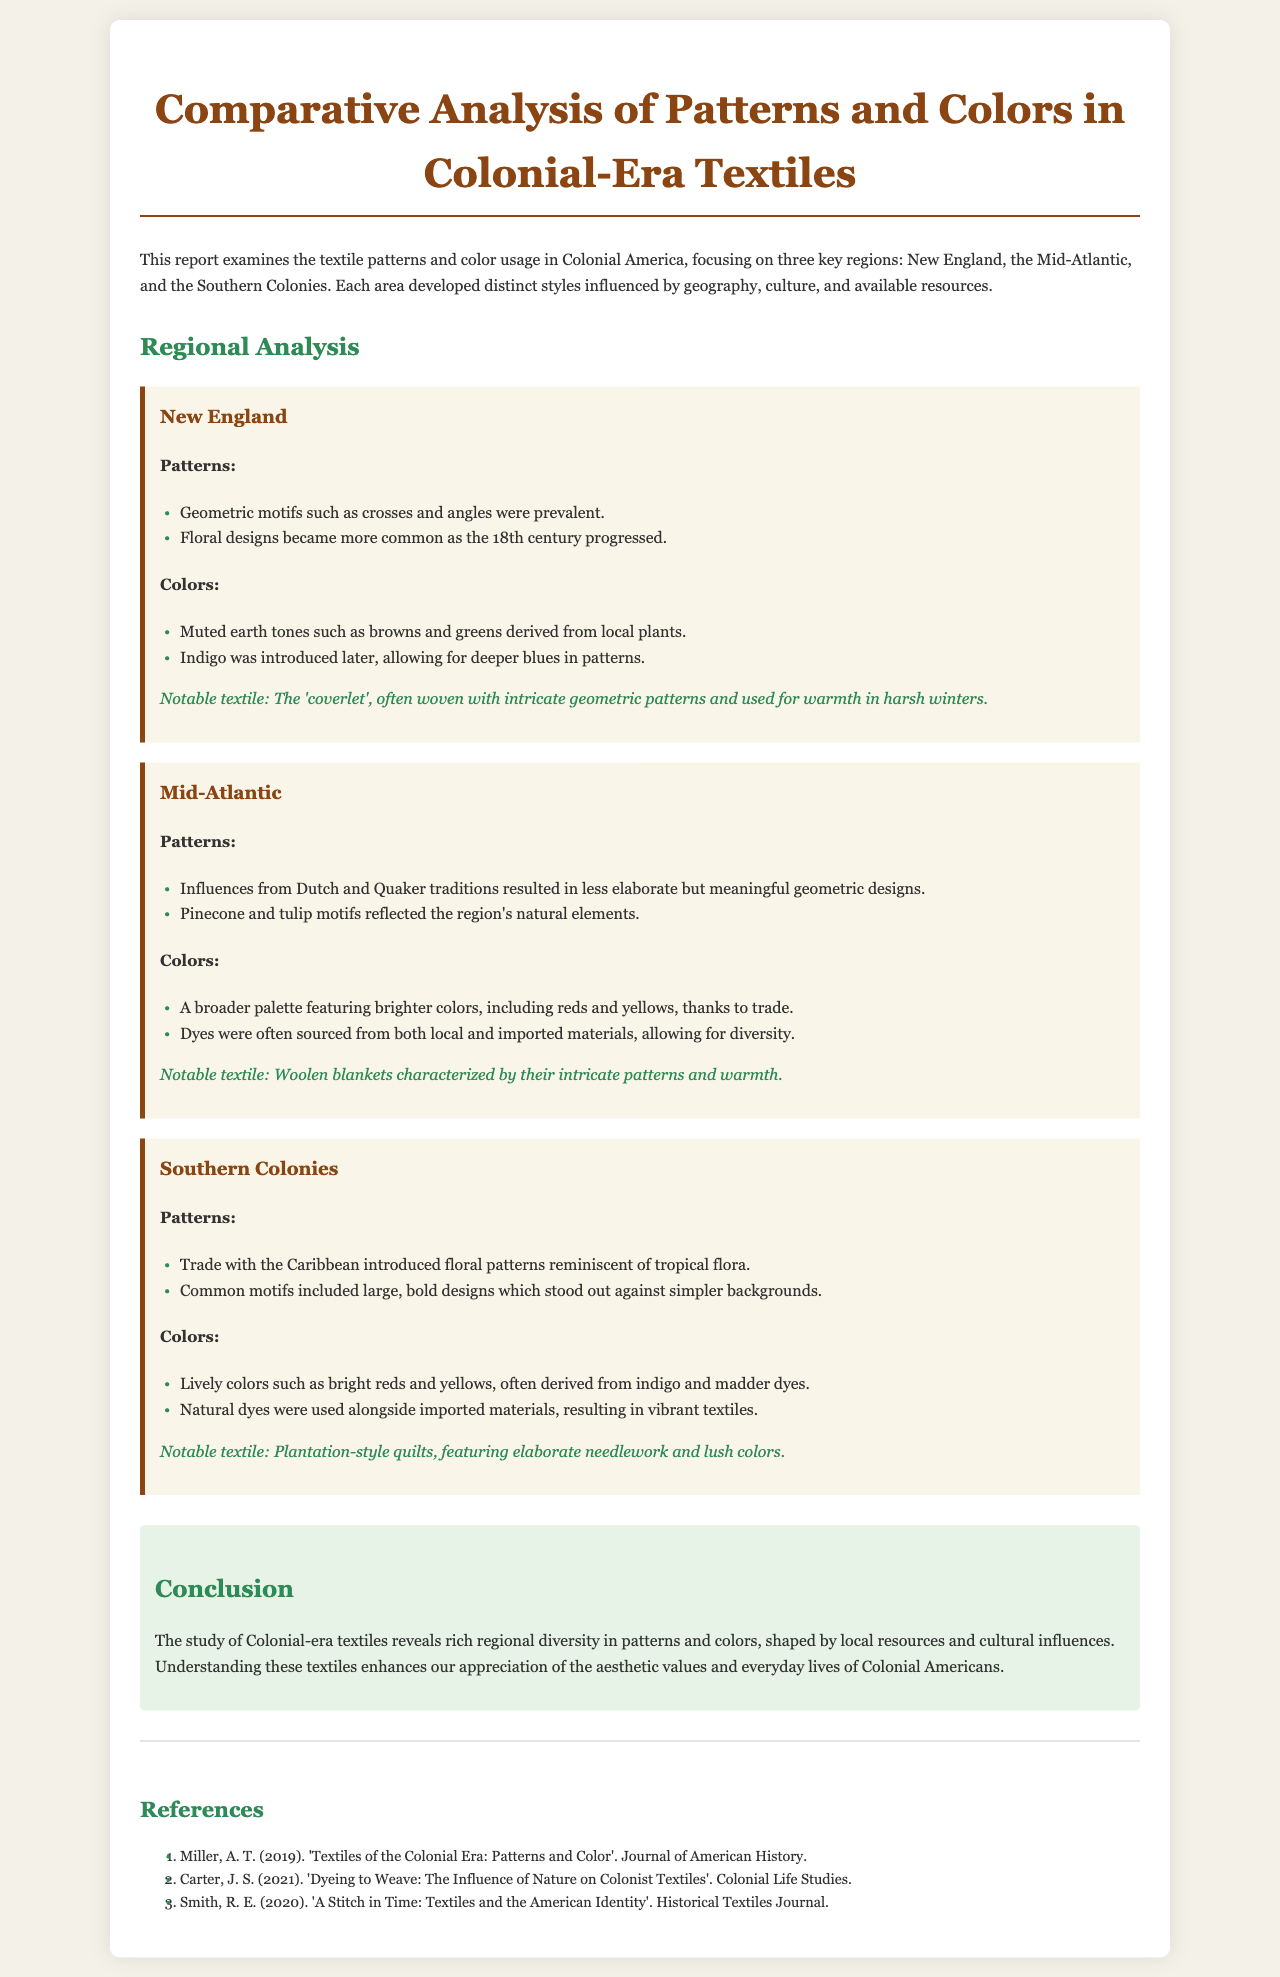What are the key regions examined in the report? The report focuses on three key regions: New England, the Mid-Atlantic, and the Southern Colonies.
Answer: New England, Mid-Atlantic, Southern Colonies What patterns are prevalent in New England textiles? The prevalent patterns in New England textiles include geometric motifs and floral designs.
Answer: Geometric motifs, floral designs What colors were introduced later in New England textiles? The introduction of indigo allowed for deeper blues in patterns in New England textiles.
Answer: Deeper blues Which region's textiles featured influences from Dutch and Quaker traditions? The Mid-Atlantic region's textiles showed influences from Dutch and Quaker traditions.
Answer: Mid-Atlantic What notable textile is associated with the Southern Colonies? The plantation-style quilts, characterized by elaborate needlework and lush colors, are notable textiles in the Southern Colonies.
Answer: Plantation-style quilts 